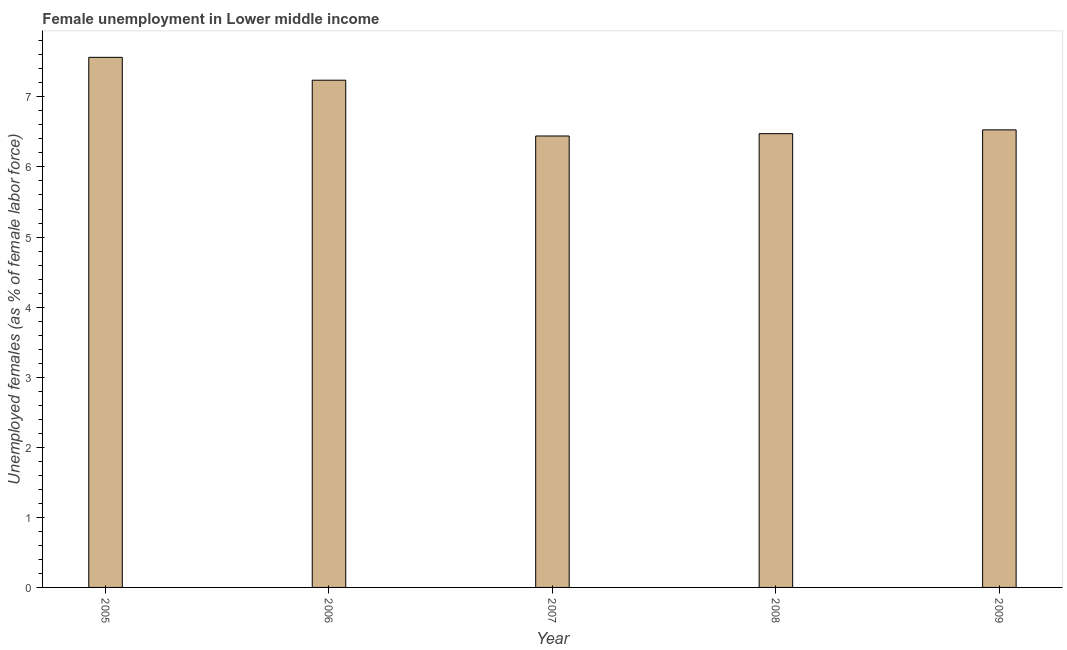Does the graph contain any zero values?
Offer a very short reply. No. Does the graph contain grids?
Offer a very short reply. No. What is the title of the graph?
Give a very brief answer. Female unemployment in Lower middle income. What is the label or title of the Y-axis?
Your answer should be compact. Unemployed females (as % of female labor force). What is the unemployed females population in 2009?
Ensure brevity in your answer.  6.53. Across all years, what is the maximum unemployed females population?
Give a very brief answer. 7.56. Across all years, what is the minimum unemployed females population?
Keep it short and to the point. 6.44. In which year was the unemployed females population minimum?
Give a very brief answer. 2007. What is the sum of the unemployed females population?
Make the answer very short. 34.25. What is the difference between the unemployed females population in 2006 and 2008?
Provide a succinct answer. 0.76. What is the average unemployed females population per year?
Offer a terse response. 6.85. What is the median unemployed females population?
Provide a short and direct response. 6.53. In how many years, is the unemployed females population greater than 5.2 %?
Give a very brief answer. 5. Do a majority of the years between 2009 and 2005 (inclusive) have unemployed females population greater than 1.2 %?
Your response must be concise. Yes. What is the ratio of the unemployed females population in 2007 to that in 2008?
Your answer should be compact. 0.99. Is the difference between the unemployed females population in 2006 and 2008 greater than the difference between any two years?
Your response must be concise. No. What is the difference between the highest and the second highest unemployed females population?
Keep it short and to the point. 0.33. Is the sum of the unemployed females population in 2005 and 2006 greater than the maximum unemployed females population across all years?
Your answer should be compact. Yes. What is the difference between the highest and the lowest unemployed females population?
Offer a very short reply. 1.12. In how many years, is the unemployed females population greater than the average unemployed females population taken over all years?
Give a very brief answer. 2. How many bars are there?
Provide a succinct answer. 5. What is the difference between two consecutive major ticks on the Y-axis?
Provide a succinct answer. 1. Are the values on the major ticks of Y-axis written in scientific E-notation?
Give a very brief answer. No. What is the Unemployed females (as % of female labor force) in 2005?
Make the answer very short. 7.56. What is the Unemployed females (as % of female labor force) in 2006?
Provide a short and direct response. 7.24. What is the Unemployed females (as % of female labor force) in 2007?
Your answer should be compact. 6.44. What is the Unemployed females (as % of female labor force) of 2008?
Your response must be concise. 6.48. What is the Unemployed females (as % of female labor force) of 2009?
Keep it short and to the point. 6.53. What is the difference between the Unemployed females (as % of female labor force) in 2005 and 2006?
Offer a terse response. 0.33. What is the difference between the Unemployed females (as % of female labor force) in 2005 and 2007?
Ensure brevity in your answer.  1.12. What is the difference between the Unemployed females (as % of female labor force) in 2005 and 2008?
Offer a very short reply. 1.09. What is the difference between the Unemployed females (as % of female labor force) in 2005 and 2009?
Provide a short and direct response. 1.03. What is the difference between the Unemployed females (as % of female labor force) in 2006 and 2007?
Your answer should be very brief. 0.8. What is the difference between the Unemployed females (as % of female labor force) in 2006 and 2008?
Offer a very short reply. 0.76. What is the difference between the Unemployed females (as % of female labor force) in 2006 and 2009?
Offer a very short reply. 0.71. What is the difference between the Unemployed females (as % of female labor force) in 2007 and 2008?
Your answer should be very brief. -0.03. What is the difference between the Unemployed females (as % of female labor force) in 2007 and 2009?
Offer a terse response. -0.09. What is the difference between the Unemployed females (as % of female labor force) in 2008 and 2009?
Provide a succinct answer. -0.05. What is the ratio of the Unemployed females (as % of female labor force) in 2005 to that in 2006?
Make the answer very short. 1.04. What is the ratio of the Unemployed females (as % of female labor force) in 2005 to that in 2007?
Your answer should be very brief. 1.17. What is the ratio of the Unemployed females (as % of female labor force) in 2005 to that in 2008?
Give a very brief answer. 1.17. What is the ratio of the Unemployed females (as % of female labor force) in 2005 to that in 2009?
Give a very brief answer. 1.16. What is the ratio of the Unemployed females (as % of female labor force) in 2006 to that in 2007?
Offer a terse response. 1.12. What is the ratio of the Unemployed females (as % of female labor force) in 2006 to that in 2008?
Offer a terse response. 1.12. What is the ratio of the Unemployed females (as % of female labor force) in 2006 to that in 2009?
Keep it short and to the point. 1.11. What is the ratio of the Unemployed females (as % of female labor force) in 2008 to that in 2009?
Offer a terse response. 0.99. 